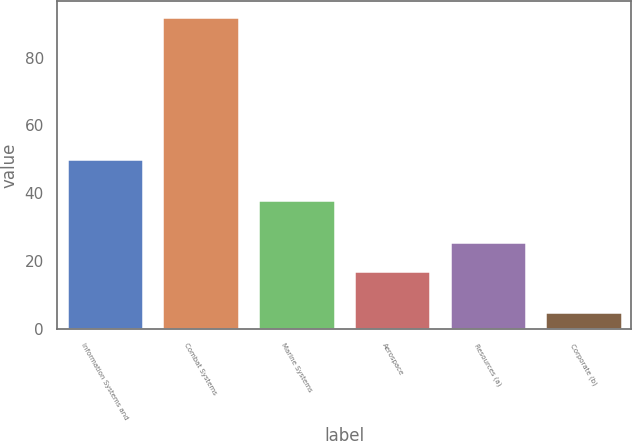<chart> <loc_0><loc_0><loc_500><loc_500><bar_chart><fcel>Information Systems and<fcel>Combat Systems<fcel>Marine Systems<fcel>Aerospace<fcel>Resources (a)<fcel>Corporate (b)<nl><fcel>50<fcel>92<fcel>38<fcel>17<fcel>25.7<fcel>5<nl></chart> 